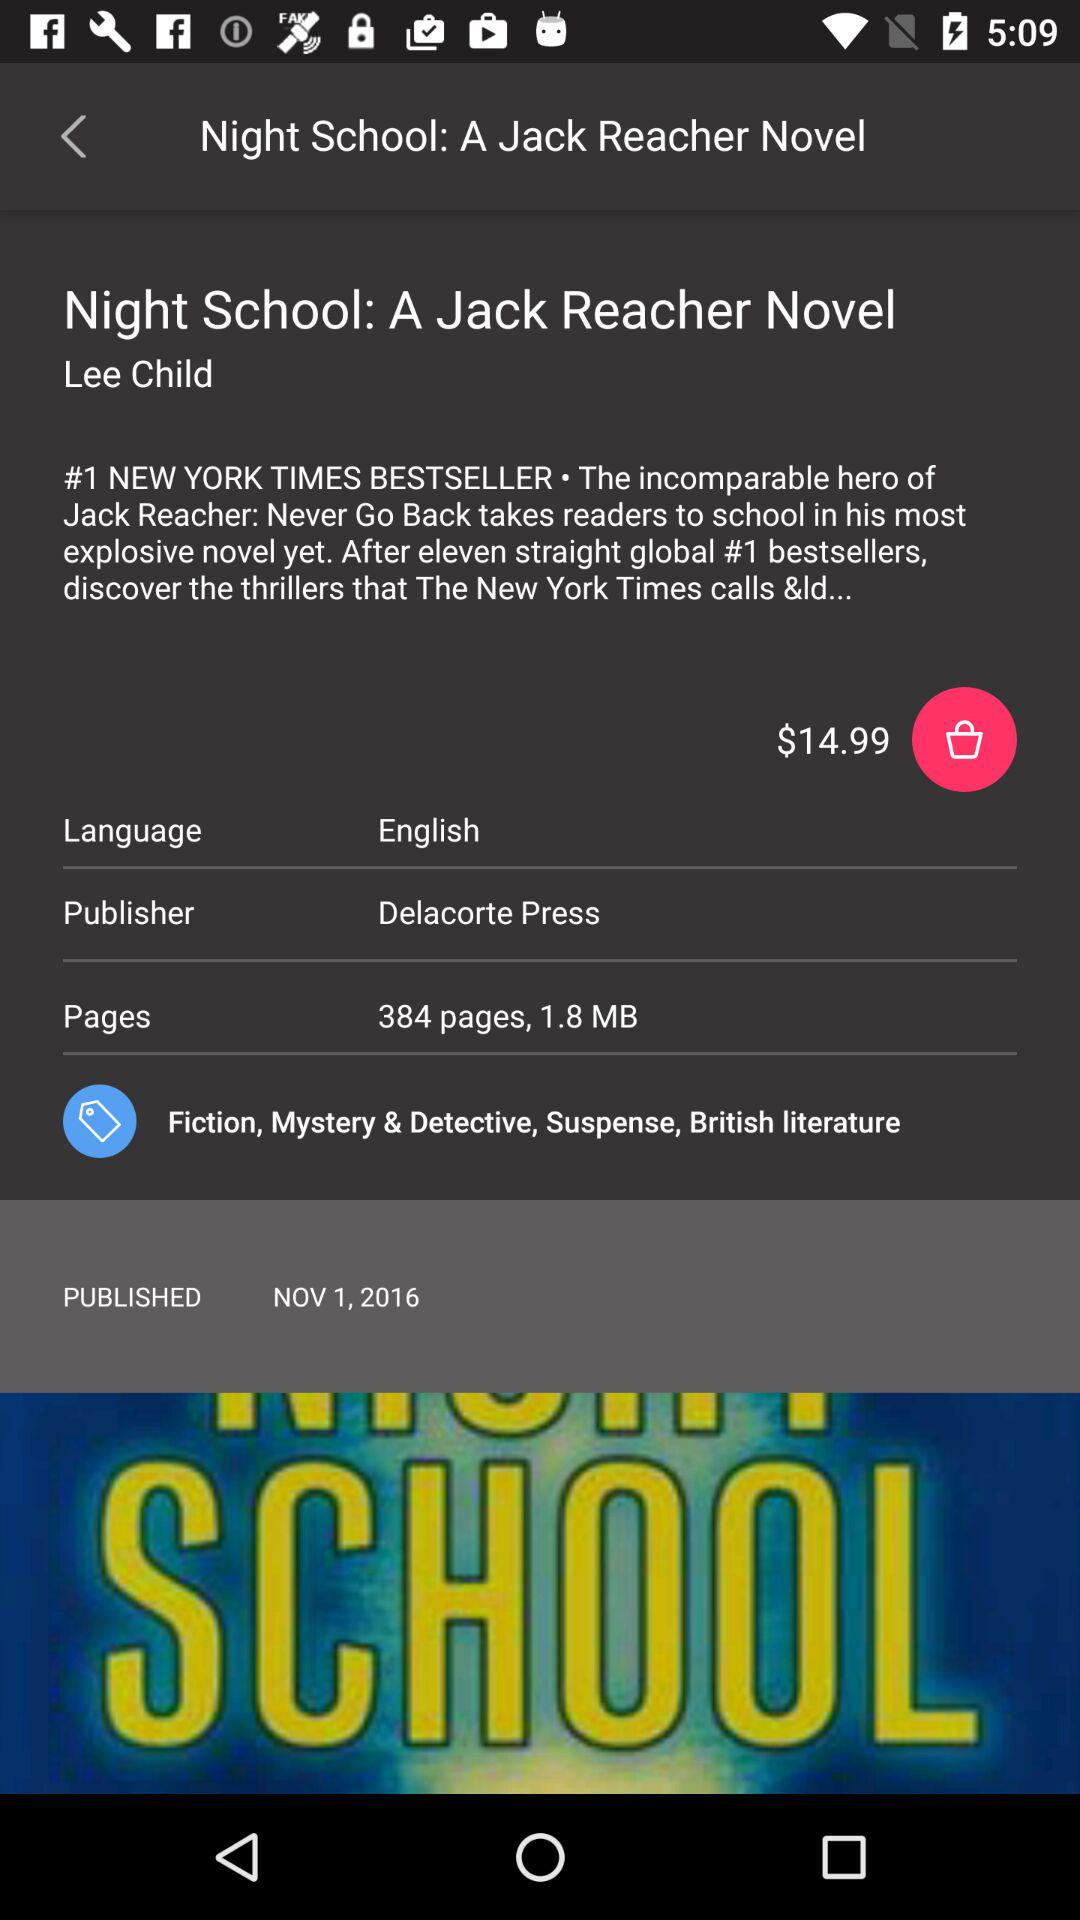What is the read time of "Night School: A Jack Reacher Novel"?
When the provided information is insufficient, respond with <no answer>. <no answer> 